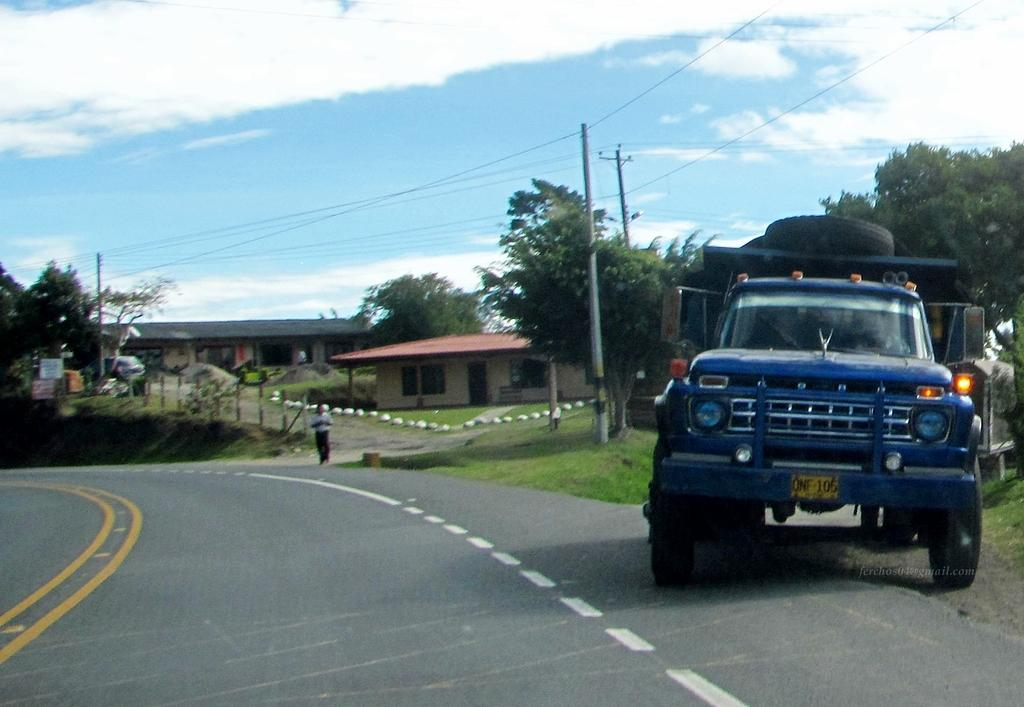What types of objects can be seen in the image? There are vehicles, trees, houses, poles, boards, and a person standing in the image. What is the nature of the road in the image? The road has lines in the image. What can be seen in the sky? The sky is visible at the top of the image, and there are clouds in the sky. Are there any wires visible in the image? Yes, there are wires visible in the image. What type of toy can be seen playing with a quarter in the image? There is no toy or quarter present in the image. Can you describe the spark coming from the person's hand in the image? There is no spark or any indication of electricity in the image; it only shows a person standing. 